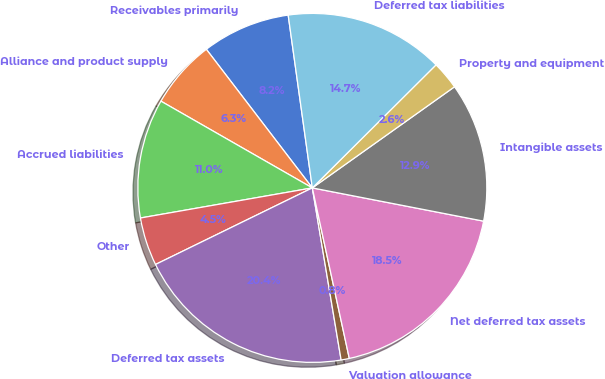<chart> <loc_0><loc_0><loc_500><loc_500><pie_chart><fcel>Receivables primarily<fcel>Alliance and product supply<fcel>Accrued liabilities<fcel>Other<fcel>Deferred tax assets<fcel>Valuation allowance<fcel>Net deferred tax assets<fcel>Intangible assets<fcel>Property and equipment<fcel>Deferred tax liabilities<nl><fcel>8.18%<fcel>6.33%<fcel>11.04%<fcel>4.47%<fcel>20.41%<fcel>0.76%<fcel>18.55%<fcel>12.89%<fcel>2.62%<fcel>14.75%<nl></chart> 